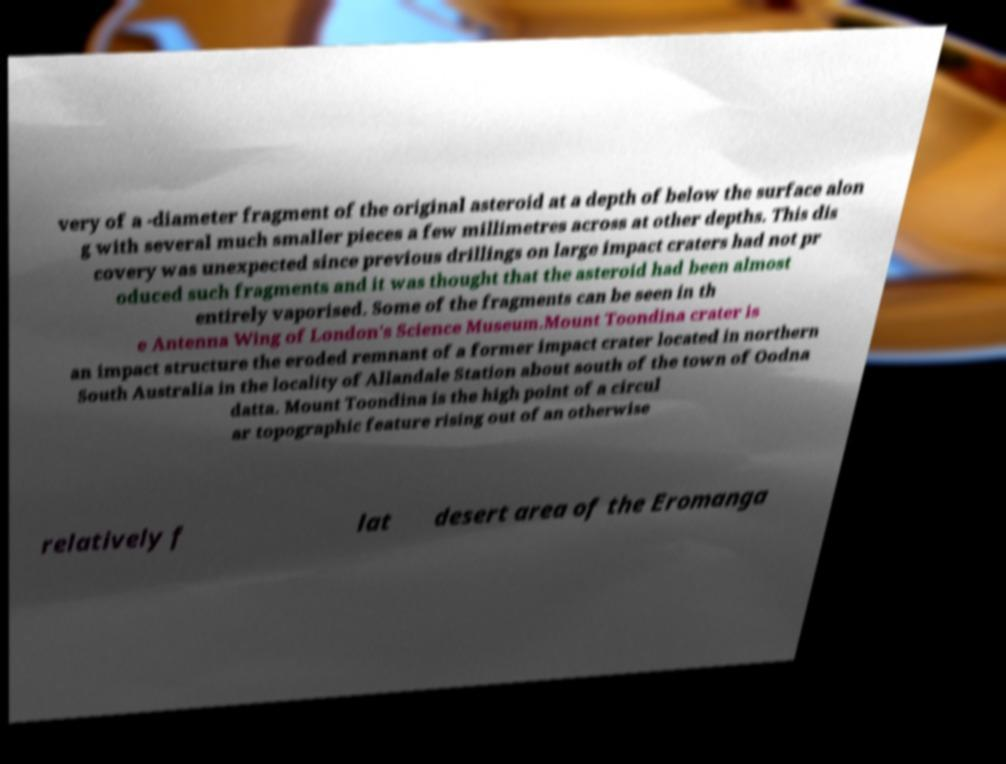Please read and relay the text visible in this image. What does it say? very of a -diameter fragment of the original asteroid at a depth of below the surface alon g with several much smaller pieces a few millimetres across at other depths. This dis covery was unexpected since previous drillings on large impact craters had not pr oduced such fragments and it was thought that the asteroid had been almost entirely vaporised. Some of the fragments can be seen in th e Antenna Wing of London's Science Museum.Mount Toondina crater is an impact structure the eroded remnant of a former impact crater located in northern South Australia in the locality of Allandale Station about south of the town of Oodna datta. Mount Toondina is the high point of a circul ar topographic feature rising out of an otherwise relatively f lat desert area of the Eromanga 